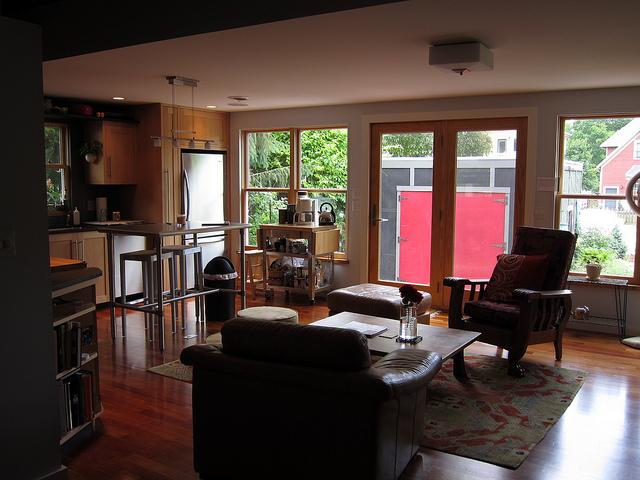How many stools are under the table?
Quick response, please. 2. Is it a sunny day?
Quick response, please. Yes. How long is the rug?
Short answer required. 10 feet. What color is the door in the back?
Answer briefly. Red. What is on the coffee table?
Write a very short answer. Flowers. Where is the tree?
Write a very short answer. Outside. 